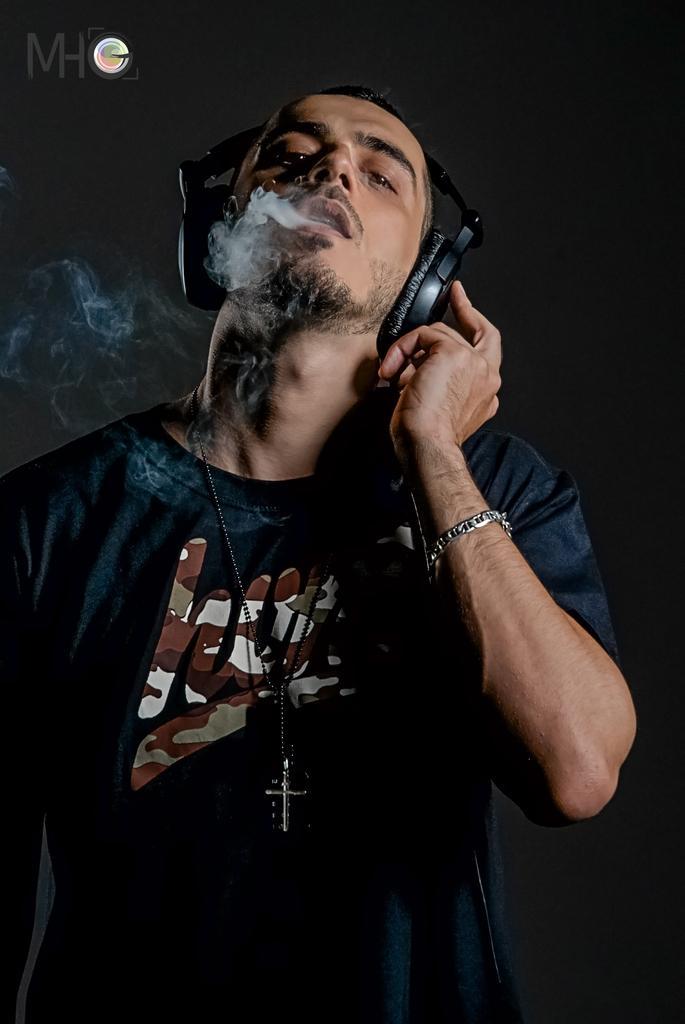Can you describe this image briefly? In front of the image there is a person wearing a headset and we can see a smoke coming from his mouth. Behind him there is a wall. There are some text and watermark at the top of the image. 